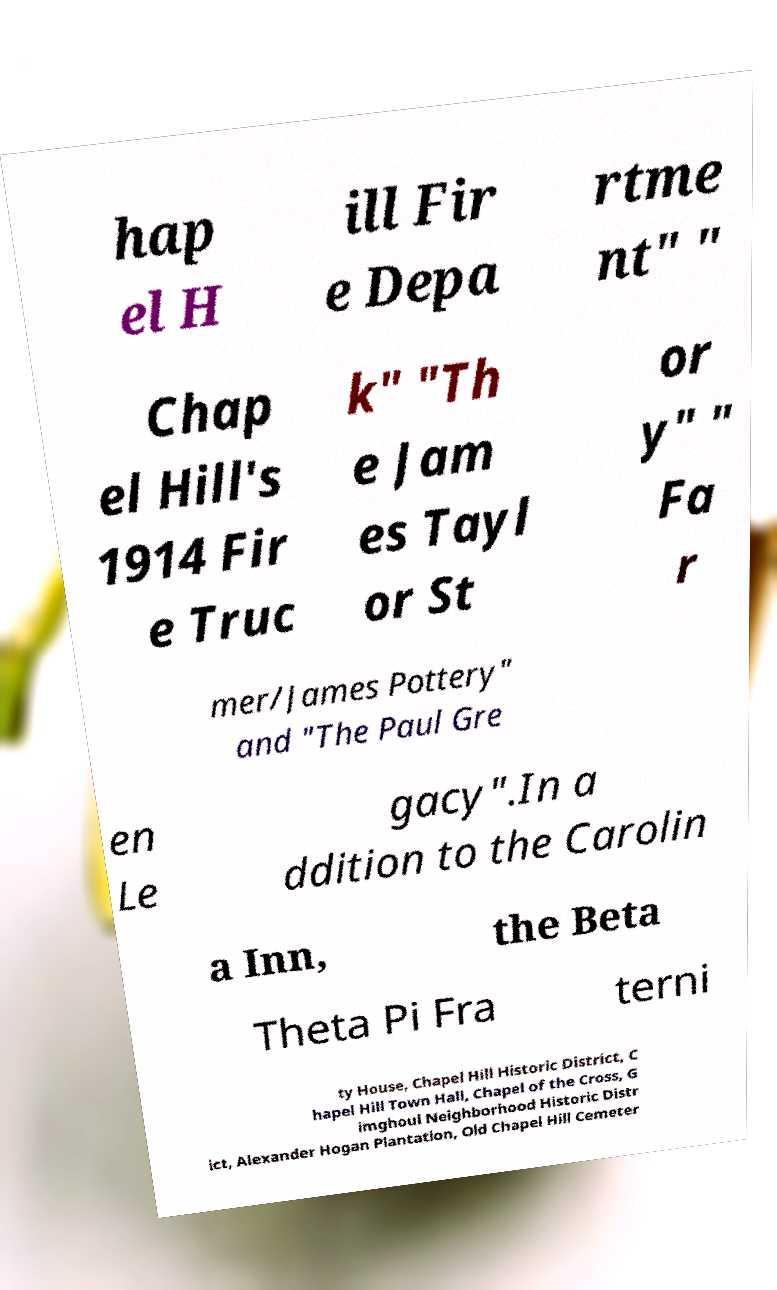Please identify and transcribe the text found in this image. hap el H ill Fir e Depa rtme nt" " Chap el Hill's 1914 Fir e Truc k" "Th e Jam es Tayl or St or y" " Fa r mer/James Pottery" and "The Paul Gre en Le gacy".In a ddition to the Carolin a Inn, the Beta Theta Pi Fra terni ty House, Chapel Hill Historic District, C hapel Hill Town Hall, Chapel of the Cross, G imghoul Neighborhood Historic Distr ict, Alexander Hogan Plantation, Old Chapel Hill Cemeter 